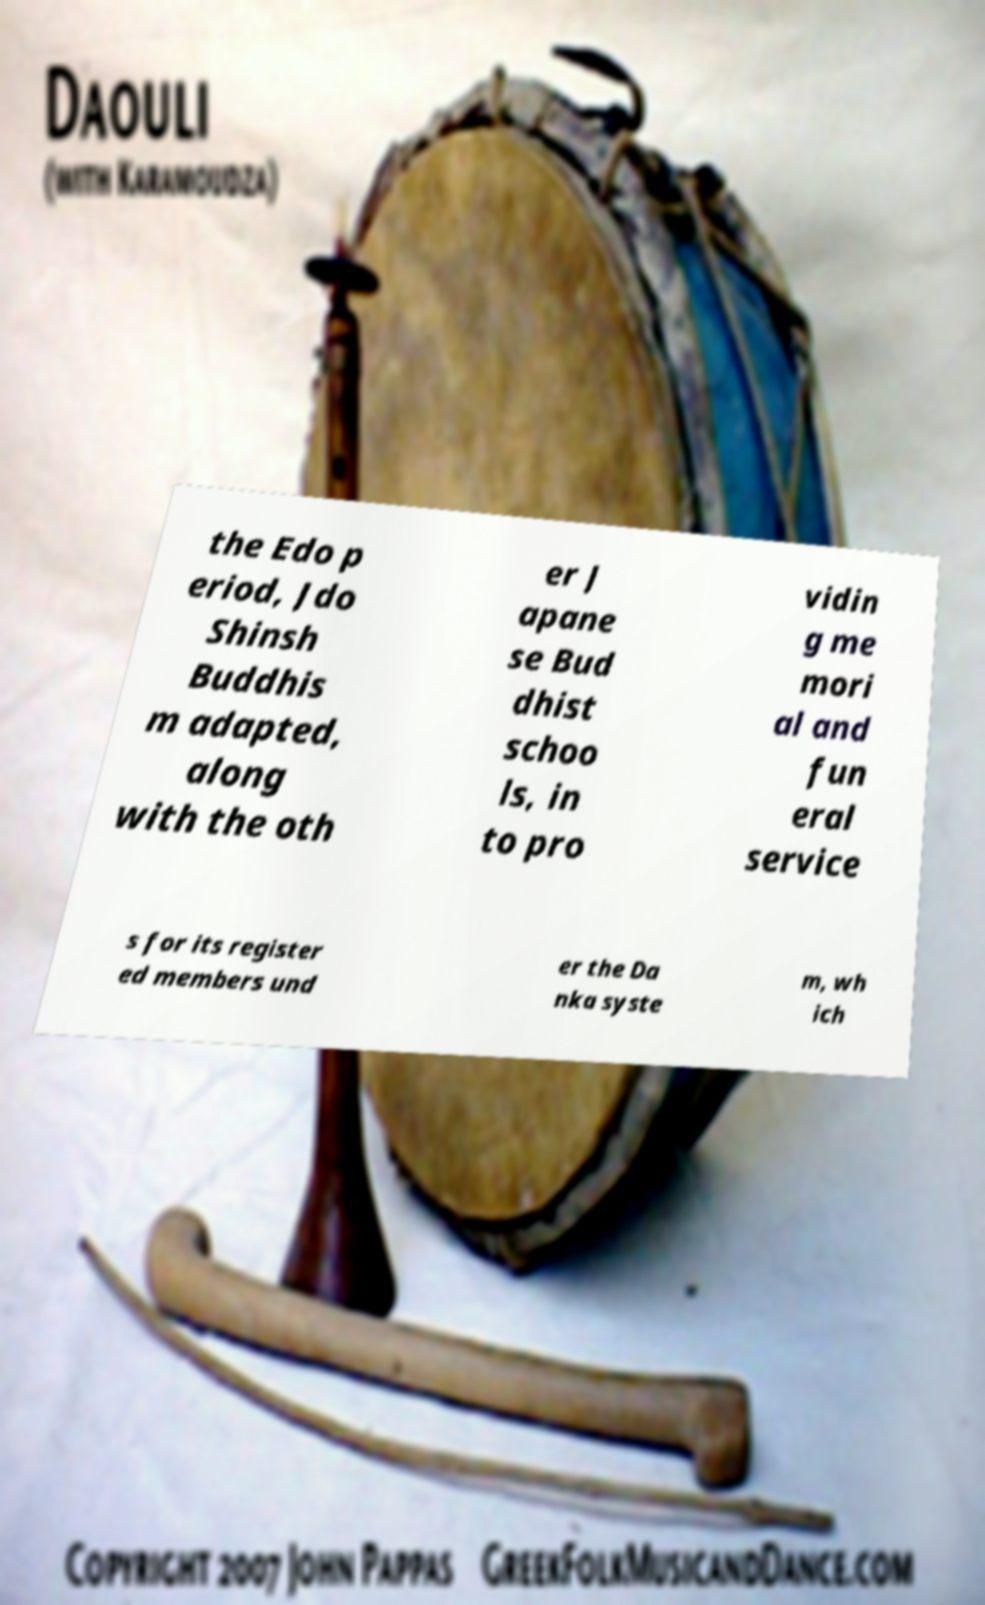Could you assist in decoding the text presented in this image and type it out clearly? the Edo p eriod, Jdo Shinsh Buddhis m adapted, along with the oth er J apane se Bud dhist schoo ls, in to pro vidin g me mori al and fun eral service s for its register ed members und er the Da nka syste m, wh ich 